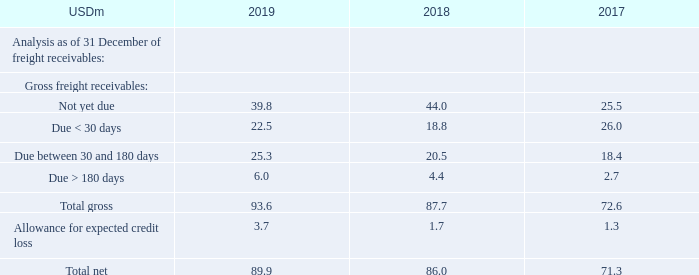NOTE 10 – FREIGHT RECEIVABLES
As of 31 December 2019, freight receivables included receivables at a value of USD 0.0m (2018: USD 0.0m 2017: USD 0.0m) that are individually determined to be impaired to a value of USD 0.0m (2018: USD 0.0m, 2017: USD 0.0m).
Management makes allowance for expected credit loss based on the simplified approach to provide for expected credit losses, which permits the use of the lifetime expected loss provision for all trade receivables. Expected credit loss for receivables overdue more than 180 days is 25%-100%, depending on category. Expected credit loss for receivables overdue more than one year is 100%.
As of 2019, what did freight receivables include? Receivables at a value of usd 0.0m (2018: usd 0.0m 2017: usd 0.0m) that are individually determined to be impaired to a value of usd 0.0m (2018: usd 0.0m, 2017: usd 0.0m). What is the making of allowance for expected credit loss based on? The simplified approach to provide for expected credit losses, which permits the use of the lifetime expected loss provision for all trade receivables. For which years were the gross freight receivables recorded in? 2019, 2018, 2017. In which year was the amount of total gross freight receivables the largest? 93.6>87.7>72.6
Answer: 2019. What was the change in the total net gross freight receivables in 2019 from 2018?
Answer scale should be: million. 89.9-86.0
Answer: 3.9. What was the percentage change in the total net gross freight receivables in 2019 from 2018?
Answer scale should be: percent. (89.9-86.0)/86.0
Answer: 4.53. 